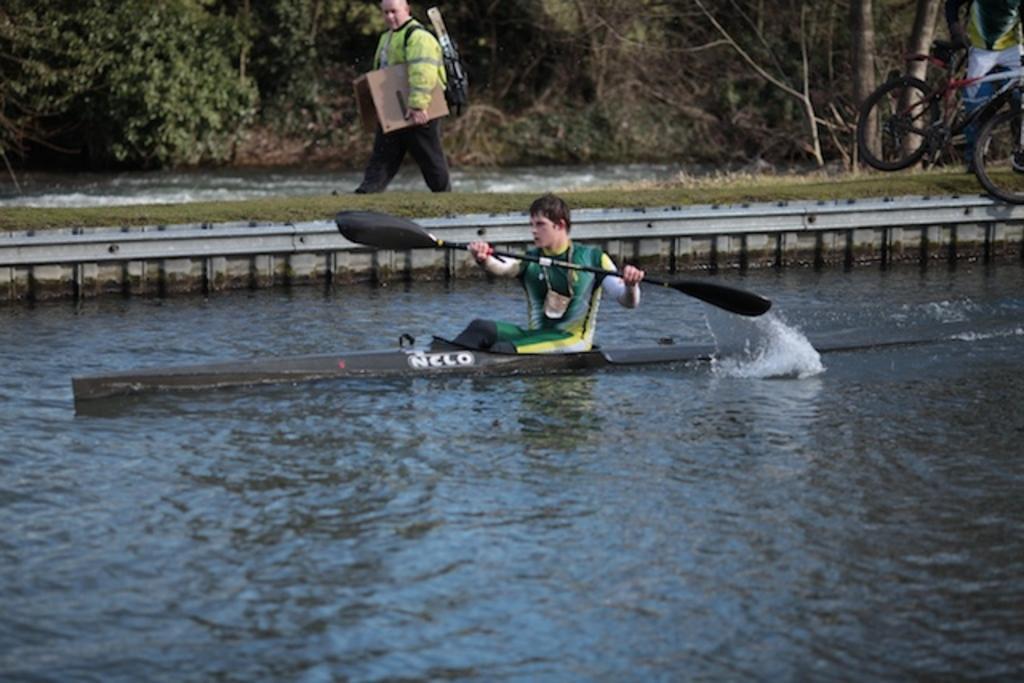In one or two sentences, can you explain what this image depicts? In the center of the image we can see person on boat sailing on the water. In the background we can see person walking, grass, bicycle, water and trees. 